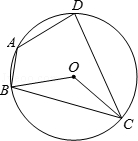What can you infer about the angles at points A and C within this circle? In a circle, the opposite angles of an inscribed quadrilateral sum up to 180 degrees. This means that the angles at points A and C, being opposite each other, add up to 180 degrees. Such properties are fundamental in the study of cyclic quadrilaterals in geometry. 